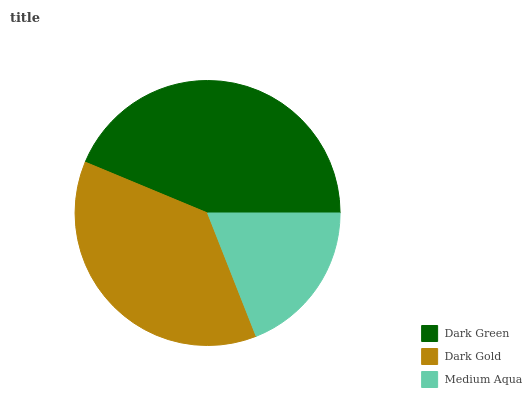Is Medium Aqua the minimum?
Answer yes or no. Yes. Is Dark Green the maximum?
Answer yes or no. Yes. Is Dark Gold the minimum?
Answer yes or no. No. Is Dark Gold the maximum?
Answer yes or no. No. Is Dark Green greater than Dark Gold?
Answer yes or no. Yes. Is Dark Gold less than Dark Green?
Answer yes or no. Yes. Is Dark Gold greater than Dark Green?
Answer yes or no. No. Is Dark Green less than Dark Gold?
Answer yes or no. No. Is Dark Gold the high median?
Answer yes or no. Yes. Is Dark Gold the low median?
Answer yes or no. Yes. Is Medium Aqua the high median?
Answer yes or no. No. Is Dark Green the low median?
Answer yes or no. No. 